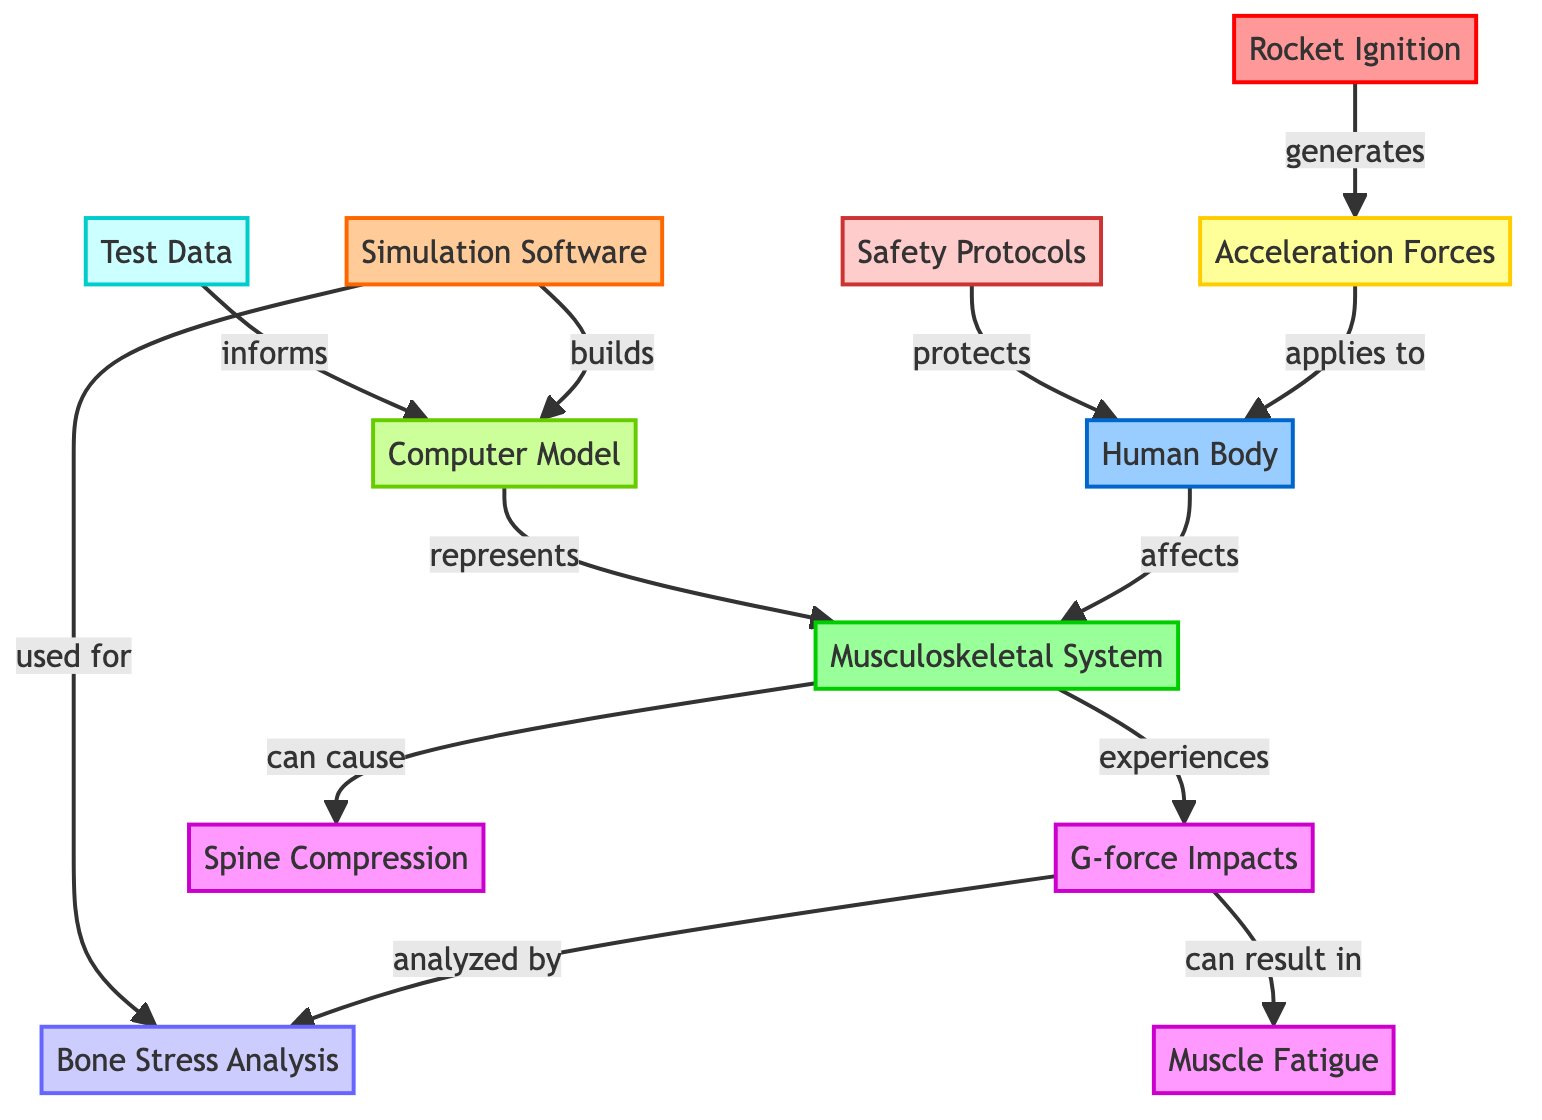What generates the Acceleration Forces? The diagram indicates that Rocket Ignition generates the Acceleration Forces. This relationship is directly indicated by the arrow connecting these two nodes.
Answer: Rocket Ignition What is affected by the Human Body? The diagram shows that the Musculoskeletal System is affected by the Human Body, as indicated by the arrow directed from the Human Body to the Musculoskeletal System.
Answer: Musculoskeletal System What can result from G-force Impacts? According to the diagram, G-force Impacts can result in Muscle Fatigue. This is explicitly stated with an arrow leading from G-force Impacts to Muscle Fatigue.
Answer: Muscle Fatigue How many effects are listed in the diagram? The diagram includes three specific effects: G-force Impacts, Spine Compression, and Muscle Fatigue. By counting the distinct effect nodes, we find a total of three.
Answer: 3 Which tool is used for Bone Stress Analysis? The diagram states that Simulation Software is used for Bone Stress Analysis. This connection is made through the arrow leading from Simulation Software to Bone Stress Analysis.
Answer: Simulation Software What protocol is mentioned that protects the Human Body? The diagram specifies that Safety Protocols protect the Human Body, indicated by the arrow going from Safety Protocols to the Human Body.
Answer: Safety Protocols What can cause Spine Compression? The diagram indicates that the Musculoskeletal System can cause Spine Compression, as shown by the arrow from Musculoskeletal System to Spine Compression.
Answer: Musculoskeletal System What does the Computer Model represent? The diagram indicates that the Computer Model represents the Musculoskeletal System, as shown by the arrow connecting these two nodes.
Answer: Musculoskeletal System 